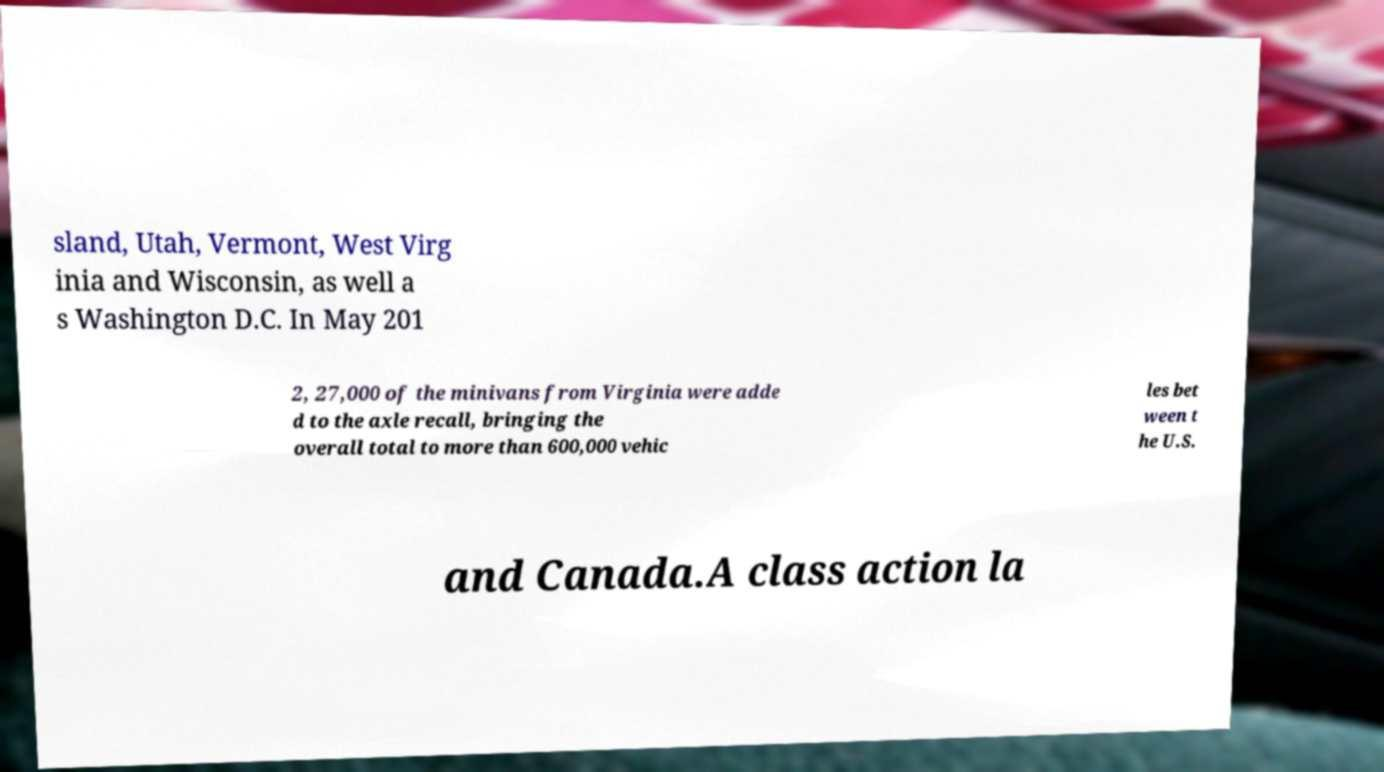There's text embedded in this image that I need extracted. Can you transcribe it verbatim? sland, Utah, Vermont, West Virg inia and Wisconsin, as well a s Washington D.C. In May 201 2, 27,000 of the minivans from Virginia were adde d to the axle recall, bringing the overall total to more than 600,000 vehic les bet ween t he U.S. and Canada.A class action la 